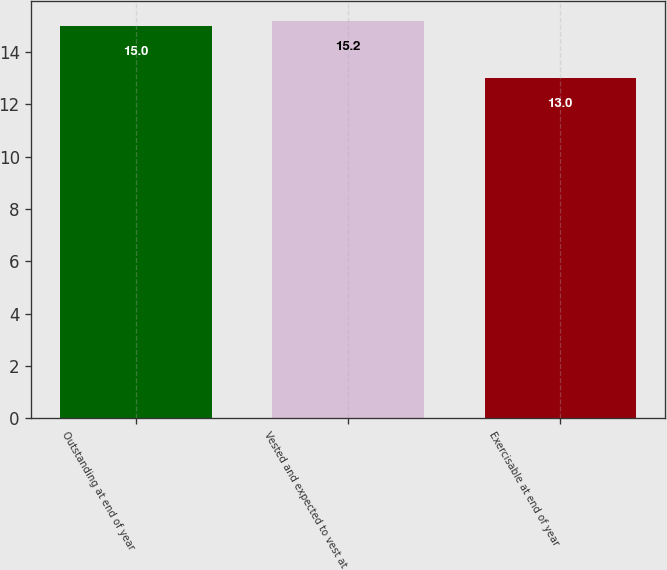<chart> <loc_0><loc_0><loc_500><loc_500><bar_chart><fcel>Outstanding at end of year<fcel>Vested and expected to vest at<fcel>Exercisable at end of year<nl><fcel>15<fcel>15.2<fcel>13<nl></chart> 